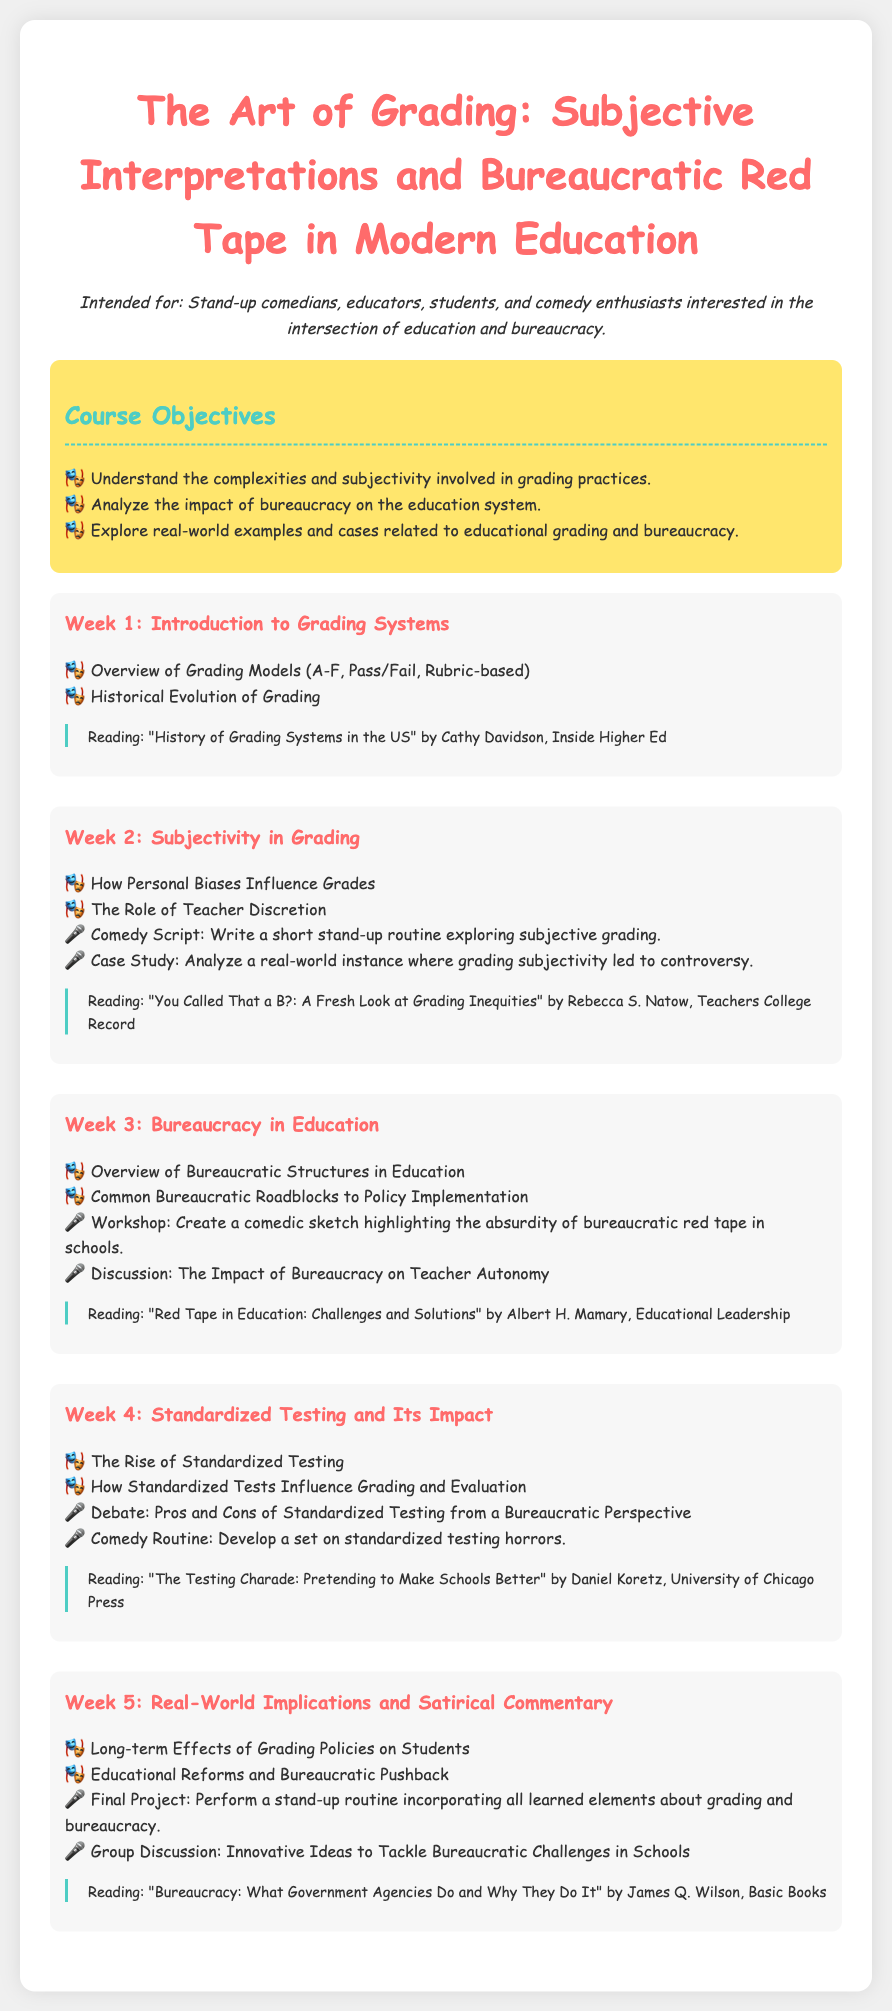What is the title of the syllabus? The title is explicitly stated at the top of the document.
Answer: The Art of Grading: Subjective Interpretations and Bureaucratic Red Tape in Modern Education Who is the intended audience for this syllabus? The intended audience is mentioned in a specific section highlighting who the course is for.
Answer: Stand-up comedians, educators, students, and comedy enthusiasts What is one of the course objectives? The document lists several course objectives, one of which can be cited.
Answer: Understand the complexities and subjectivity involved in grading practices What is the focus of Week 3? Each week is focused on specific themes as outlined in the individual sections.
Answer: Bureaucracy in Education Name one reading assigned for Week 4. The document includes a reading for each week; one can be specified for Week 4.
Answer: "The Testing Charade: Pretending to Make Schools Better" by Daniel Koretz, University of Chicago Press What type of activity is included in Week 2? The syllabus outlines various activities for each week, indicating the nature of those activities.
Answer: Write a short stand-up routine exploring subjective grading 